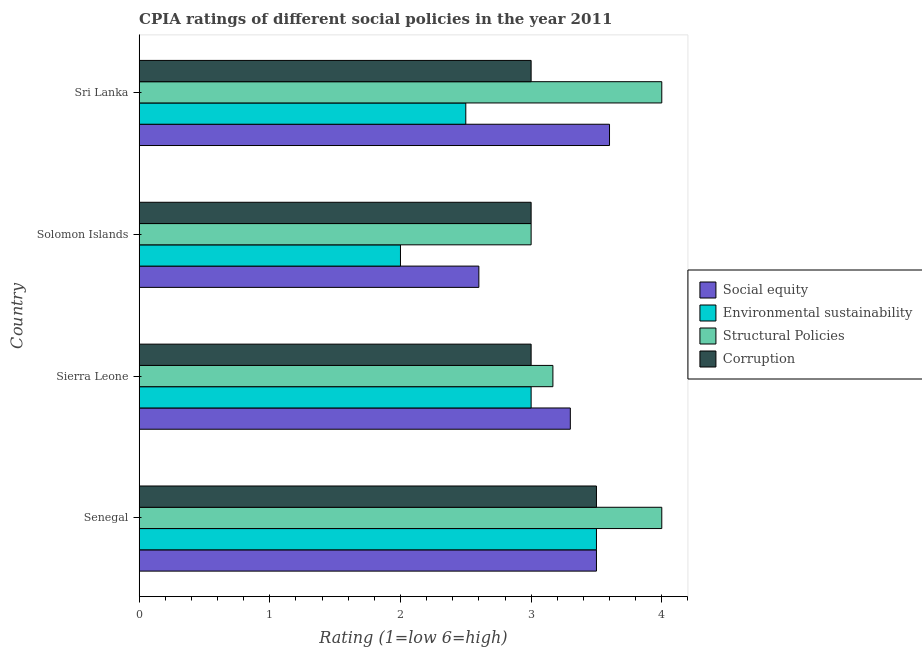How many groups of bars are there?
Provide a short and direct response. 4. How many bars are there on the 2nd tick from the top?
Offer a very short reply. 4. How many bars are there on the 3rd tick from the bottom?
Keep it short and to the point. 4. What is the label of the 2nd group of bars from the top?
Provide a short and direct response. Solomon Islands. What is the cpia rating of environmental sustainability in Sierra Leone?
Offer a very short reply. 3. Across all countries, what is the maximum cpia rating of corruption?
Offer a very short reply. 3.5. In which country was the cpia rating of corruption maximum?
Your answer should be very brief. Senegal. In which country was the cpia rating of environmental sustainability minimum?
Offer a terse response. Solomon Islands. What is the total cpia rating of corruption in the graph?
Give a very brief answer. 12.5. What is the difference between the cpia rating of social equity in Solomon Islands and the cpia rating of environmental sustainability in Senegal?
Provide a succinct answer. -0.9. What is the average cpia rating of corruption per country?
Your answer should be compact. 3.12. In how many countries, is the cpia rating of social equity greater than 0.6000000000000001 ?
Your answer should be very brief. 4. What is the ratio of the cpia rating of social equity in Sierra Leone to that in Solomon Islands?
Provide a short and direct response. 1.27. Is the difference between the cpia rating of corruption in Sierra Leone and Solomon Islands greater than the difference between the cpia rating of environmental sustainability in Sierra Leone and Solomon Islands?
Give a very brief answer. No. Is the sum of the cpia rating of corruption in Sierra Leone and Solomon Islands greater than the maximum cpia rating of environmental sustainability across all countries?
Ensure brevity in your answer.  Yes. Is it the case that in every country, the sum of the cpia rating of social equity and cpia rating of environmental sustainability is greater than the sum of cpia rating of corruption and cpia rating of structural policies?
Your answer should be very brief. No. What does the 1st bar from the top in Sri Lanka represents?
Your answer should be very brief. Corruption. What does the 2nd bar from the bottom in Senegal represents?
Offer a very short reply. Environmental sustainability. How many bars are there?
Your answer should be very brief. 16. Are all the bars in the graph horizontal?
Offer a very short reply. Yes. Does the graph contain any zero values?
Offer a terse response. No. Where does the legend appear in the graph?
Provide a succinct answer. Center right. How many legend labels are there?
Your response must be concise. 4. How are the legend labels stacked?
Your answer should be very brief. Vertical. What is the title of the graph?
Give a very brief answer. CPIA ratings of different social policies in the year 2011. Does "Pre-primary schools" appear as one of the legend labels in the graph?
Your answer should be compact. No. What is the label or title of the Y-axis?
Give a very brief answer. Country. What is the Rating (1=low 6=high) of Environmental sustainability in Senegal?
Provide a short and direct response. 3.5. What is the Rating (1=low 6=high) of Corruption in Senegal?
Keep it short and to the point. 3.5. What is the Rating (1=low 6=high) of Structural Policies in Sierra Leone?
Give a very brief answer. 3.17. What is the Rating (1=low 6=high) in Environmental sustainability in Solomon Islands?
Keep it short and to the point. 2. What is the Rating (1=low 6=high) of Corruption in Solomon Islands?
Provide a short and direct response. 3. What is the Rating (1=low 6=high) of Corruption in Sri Lanka?
Provide a short and direct response. 3. Across all countries, what is the maximum Rating (1=low 6=high) of Environmental sustainability?
Make the answer very short. 3.5. Across all countries, what is the maximum Rating (1=low 6=high) in Structural Policies?
Your response must be concise. 4. Across all countries, what is the maximum Rating (1=low 6=high) of Corruption?
Offer a terse response. 3.5. Across all countries, what is the minimum Rating (1=low 6=high) in Social equity?
Offer a very short reply. 2.6. Across all countries, what is the minimum Rating (1=low 6=high) in Corruption?
Ensure brevity in your answer.  3. What is the total Rating (1=low 6=high) of Social equity in the graph?
Your answer should be very brief. 13. What is the total Rating (1=low 6=high) in Structural Policies in the graph?
Your answer should be compact. 14.17. What is the difference between the Rating (1=low 6=high) of Environmental sustainability in Senegal and that in Sierra Leone?
Keep it short and to the point. 0.5. What is the difference between the Rating (1=low 6=high) in Environmental sustainability in Senegal and that in Solomon Islands?
Keep it short and to the point. 1.5. What is the difference between the Rating (1=low 6=high) in Corruption in Senegal and that in Solomon Islands?
Your answer should be compact. 0.5. What is the difference between the Rating (1=low 6=high) of Social equity in Senegal and that in Sri Lanka?
Give a very brief answer. -0.1. What is the difference between the Rating (1=low 6=high) of Environmental sustainability in Sierra Leone and that in Solomon Islands?
Offer a very short reply. 1. What is the difference between the Rating (1=low 6=high) in Structural Policies in Sierra Leone and that in Sri Lanka?
Offer a very short reply. -0.83. What is the difference between the Rating (1=low 6=high) of Environmental sustainability in Solomon Islands and that in Sri Lanka?
Provide a short and direct response. -0.5. What is the difference between the Rating (1=low 6=high) of Structural Policies in Solomon Islands and that in Sri Lanka?
Provide a short and direct response. -1. What is the difference between the Rating (1=low 6=high) of Social equity in Senegal and the Rating (1=low 6=high) of Corruption in Sierra Leone?
Make the answer very short. 0.5. What is the difference between the Rating (1=low 6=high) in Environmental sustainability in Senegal and the Rating (1=low 6=high) in Structural Policies in Sierra Leone?
Keep it short and to the point. 0.33. What is the difference between the Rating (1=low 6=high) in Social equity in Senegal and the Rating (1=low 6=high) in Environmental sustainability in Solomon Islands?
Ensure brevity in your answer.  1.5. What is the difference between the Rating (1=low 6=high) in Social equity in Senegal and the Rating (1=low 6=high) in Corruption in Solomon Islands?
Give a very brief answer. 0.5. What is the difference between the Rating (1=low 6=high) of Structural Policies in Senegal and the Rating (1=low 6=high) of Corruption in Solomon Islands?
Offer a terse response. 1. What is the difference between the Rating (1=low 6=high) of Social equity in Senegal and the Rating (1=low 6=high) of Structural Policies in Sri Lanka?
Provide a short and direct response. -0.5. What is the difference between the Rating (1=low 6=high) in Social equity in Senegal and the Rating (1=low 6=high) in Corruption in Sri Lanka?
Your response must be concise. 0.5. What is the difference between the Rating (1=low 6=high) in Environmental sustainability in Senegal and the Rating (1=low 6=high) in Corruption in Sri Lanka?
Make the answer very short. 0.5. What is the difference between the Rating (1=low 6=high) of Structural Policies in Senegal and the Rating (1=low 6=high) of Corruption in Sri Lanka?
Ensure brevity in your answer.  1. What is the difference between the Rating (1=low 6=high) of Social equity in Sierra Leone and the Rating (1=low 6=high) of Environmental sustainability in Solomon Islands?
Offer a very short reply. 1.3. What is the difference between the Rating (1=low 6=high) of Social equity in Sierra Leone and the Rating (1=low 6=high) of Structural Policies in Solomon Islands?
Your answer should be compact. 0.3. What is the difference between the Rating (1=low 6=high) in Environmental sustainability in Sierra Leone and the Rating (1=low 6=high) in Corruption in Solomon Islands?
Provide a short and direct response. 0. What is the difference between the Rating (1=low 6=high) of Structural Policies in Sierra Leone and the Rating (1=low 6=high) of Corruption in Solomon Islands?
Your response must be concise. 0.17. What is the difference between the Rating (1=low 6=high) of Social equity in Sierra Leone and the Rating (1=low 6=high) of Corruption in Sri Lanka?
Your response must be concise. 0.3. What is the difference between the Rating (1=low 6=high) of Environmental sustainability in Sierra Leone and the Rating (1=low 6=high) of Corruption in Sri Lanka?
Keep it short and to the point. 0. What is the difference between the Rating (1=low 6=high) of Structural Policies in Sierra Leone and the Rating (1=low 6=high) of Corruption in Sri Lanka?
Your answer should be very brief. 0.17. What is the difference between the Rating (1=low 6=high) in Social equity in Solomon Islands and the Rating (1=low 6=high) in Structural Policies in Sri Lanka?
Your answer should be compact. -1.4. What is the difference between the Rating (1=low 6=high) in Social equity in Solomon Islands and the Rating (1=low 6=high) in Corruption in Sri Lanka?
Provide a succinct answer. -0.4. What is the average Rating (1=low 6=high) in Environmental sustainability per country?
Offer a very short reply. 2.75. What is the average Rating (1=low 6=high) of Structural Policies per country?
Provide a short and direct response. 3.54. What is the average Rating (1=low 6=high) of Corruption per country?
Offer a very short reply. 3.12. What is the difference between the Rating (1=low 6=high) of Social equity and Rating (1=low 6=high) of Corruption in Senegal?
Give a very brief answer. 0. What is the difference between the Rating (1=low 6=high) of Environmental sustainability and Rating (1=low 6=high) of Corruption in Senegal?
Provide a short and direct response. 0. What is the difference between the Rating (1=low 6=high) in Social equity and Rating (1=low 6=high) in Structural Policies in Sierra Leone?
Your answer should be compact. 0.13. What is the difference between the Rating (1=low 6=high) of Environmental sustainability and Rating (1=low 6=high) of Structural Policies in Sierra Leone?
Your response must be concise. -0.17. What is the difference between the Rating (1=low 6=high) in Environmental sustainability and Rating (1=low 6=high) in Corruption in Sierra Leone?
Provide a short and direct response. 0. What is the difference between the Rating (1=low 6=high) in Social equity and Rating (1=low 6=high) in Structural Policies in Solomon Islands?
Your answer should be very brief. -0.4. What is the difference between the Rating (1=low 6=high) in Environmental sustainability and Rating (1=low 6=high) in Structural Policies in Solomon Islands?
Your answer should be compact. -1. What is the difference between the Rating (1=low 6=high) of Environmental sustainability and Rating (1=low 6=high) of Corruption in Solomon Islands?
Give a very brief answer. -1. What is the difference between the Rating (1=low 6=high) of Social equity and Rating (1=low 6=high) of Corruption in Sri Lanka?
Keep it short and to the point. 0.6. What is the difference between the Rating (1=low 6=high) in Environmental sustainability and Rating (1=low 6=high) in Structural Policies in Sri Lanka?
Provide a short and direct response. -1.5. What is the ratio of the Rating (1=low 6=high) of Social equity in Senegal to that in Sierra Leone?
Make the answer very short. 1.06. What is the ratio of the Rating (1=low 6=high) in Environmental sustainability in Senegal to that in Sierra Leone?
Provide a short and direct response. 1.17. What is the ratio of the Rating (1=low 6=high) in Structural Policies in Senegal to that in Sierra Leone?
Provide a short and direct response. 1.26. What is the ratio of the Rating (1=low 6=high) in Corruption in Senegal to that in Sierra Leone?
Provide a short and direct response. 1.17. What is the ratio of the Rating (1=low 6=high) of Social equity in Senegal to that in Solomon Islands?
Provide a succinct answer. 1.35. What is the ratio of the Rating (1=low 6=high) of Environmental sustainability in Senegal to that in Solomon Islands?
Your answer should be very brief. 1.75. What is the ratio of the Rating (1=low 6=high) in Corruption in Senegal to that in Solomon Islands?
Keep it short and to the point. 1.17. What is the ratio of the Rating (1=low 6=high) in Social equity in Senegal to that in Sri Lanka?
Ensure brevity in your answer.  0.97. What is the ratio of the Rating (1=low 6=high) of Environmental sustainability in Senegal to that in Sri Lanka?
Your response must be concise. 1.4. What is the ratio of the Rating (1=low 6=high) in Social equity in Sierra Leone to that in Solomon Islands?
Ensure brevity in your answer.  1.27. What is the ratio of the Rating (1=low 6=high) of Structural Policies in Sierra Leone to that in Solomon Islands?
Your answer should be compact. 1.06. What is the ratio of the Rating (1=low 6=high) in Corruption in Sierra Leone to that in Solomon Islands?
Ensure brevity in your answer.  1. What is the ratio of the Rating (1=low 6=high) in Social equity in Sierra Leone to that in Sri Lanka?
Make the answer very short. 0.92. What is the ratio of the Rating (1=low 6=high) of Structural Policies in Sierra Leone to that in Sri Lanka?
Provide a succinct answer. 0.79. What is the ratio of the Rating (1=low 6=high) of Social equity in Solomon Islands to that in Sri Lanka?
Provide a short and direct response. 0.72. What is the ratio of the Rating (1=low 6=high) of Structural Policies in Solomon Islands to that in Sri Lanka?
Give a very brief answer. 0.75. What is the ratio of the Rating (1=low 6=high) in Corruption in Solomon Islands to that in Sri Lanka?
Provide a succinct answer. 1. What is the difference between the highest and the second highest Rating (1=low 6=high) in Corruption?
Offer a terse response. 0.5. What is the difference between the highest and the lowest Rating (1=low 6=high) of Social equity?
Ensure brevity in your answer.  1. What is the difference between the highest and the lowest Rating (1=low 6=high) of Environmental sustainability?
Offer a very short reply. 1.5. 